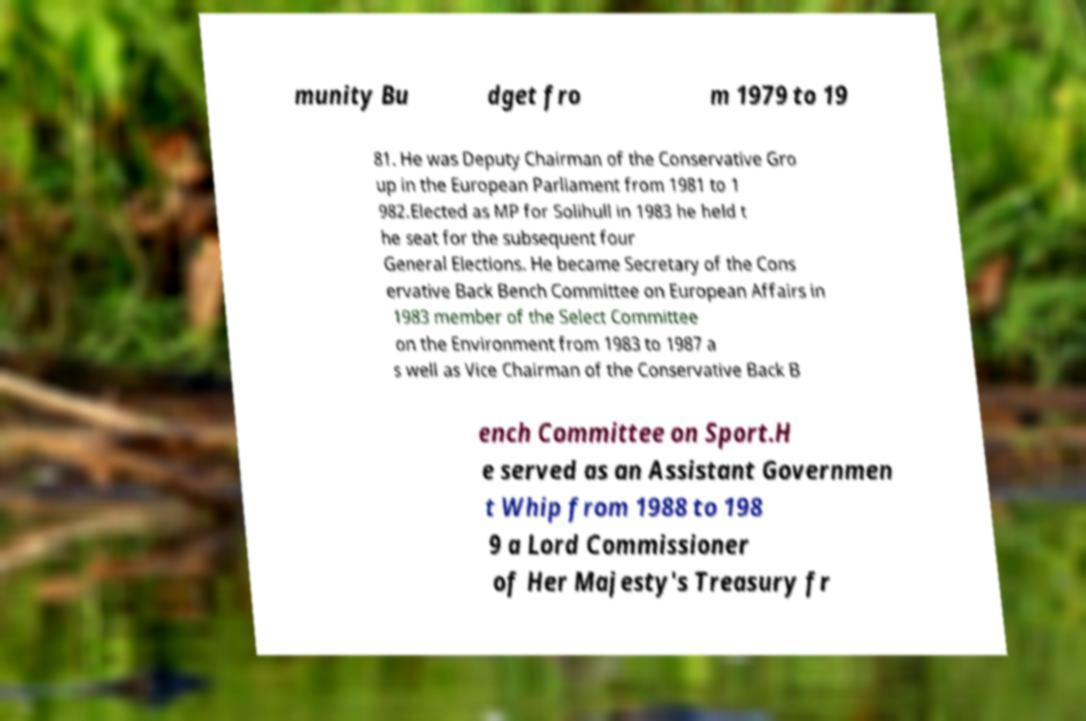What messages or text are displayed in this image? I need them in a readable, typed format. munity Bu dget fro m 1979 to 19 81. He was Deputy Chairman of the Conservative Gro up in the European Parliament from 1981 to 1 982.Elected as MP for Solihull in 1983 he held t he seat for the subsequent four General Elections. He became Secretary of the Cons ervative Back Bench Committee on European Affairs in 1983 member of the Select Committee on the Environment from 1983 to 1987 a s well as Vice Chairman of the Conservative Back B ench Committee on Sport.H e served as an Assistant Governmen t Whip from 1988 to 198 9 a Lord Commissioner of Her Majesty's Treasury fr 